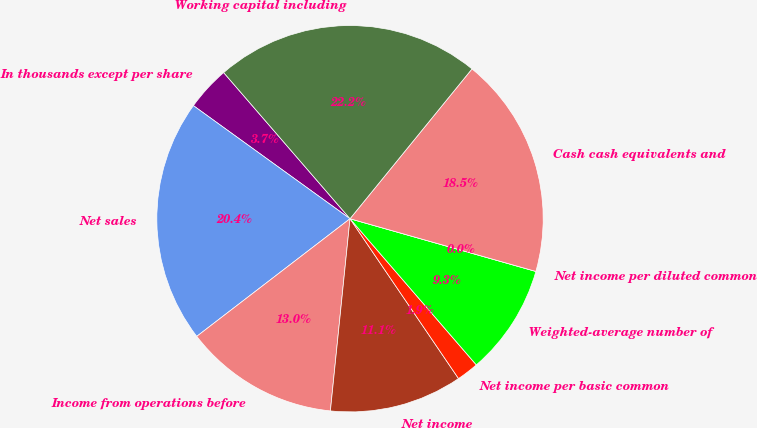Convert chart to OTSL. <chart><loc_0><loc_0><loc_500><loc_500><pie_chart><fcel>In thousands except per share<fcel>Net sales<fcel>Income from operations before<fcel>Net income<fcel>Net income per basic common<fcel>Weighted-average number of<fcel>Net income per diluted common<fcel>Cash cash equivalents and<fcel>Working capital including<nl><fcel>3.7%<fcel>20.37%<fcel>12.96%<fcel>11.11%<fcel>1.85%<fcel>9.26%<fcel>0.0%<fcel>18.52%<fcel>22.22%<nl></chart> 